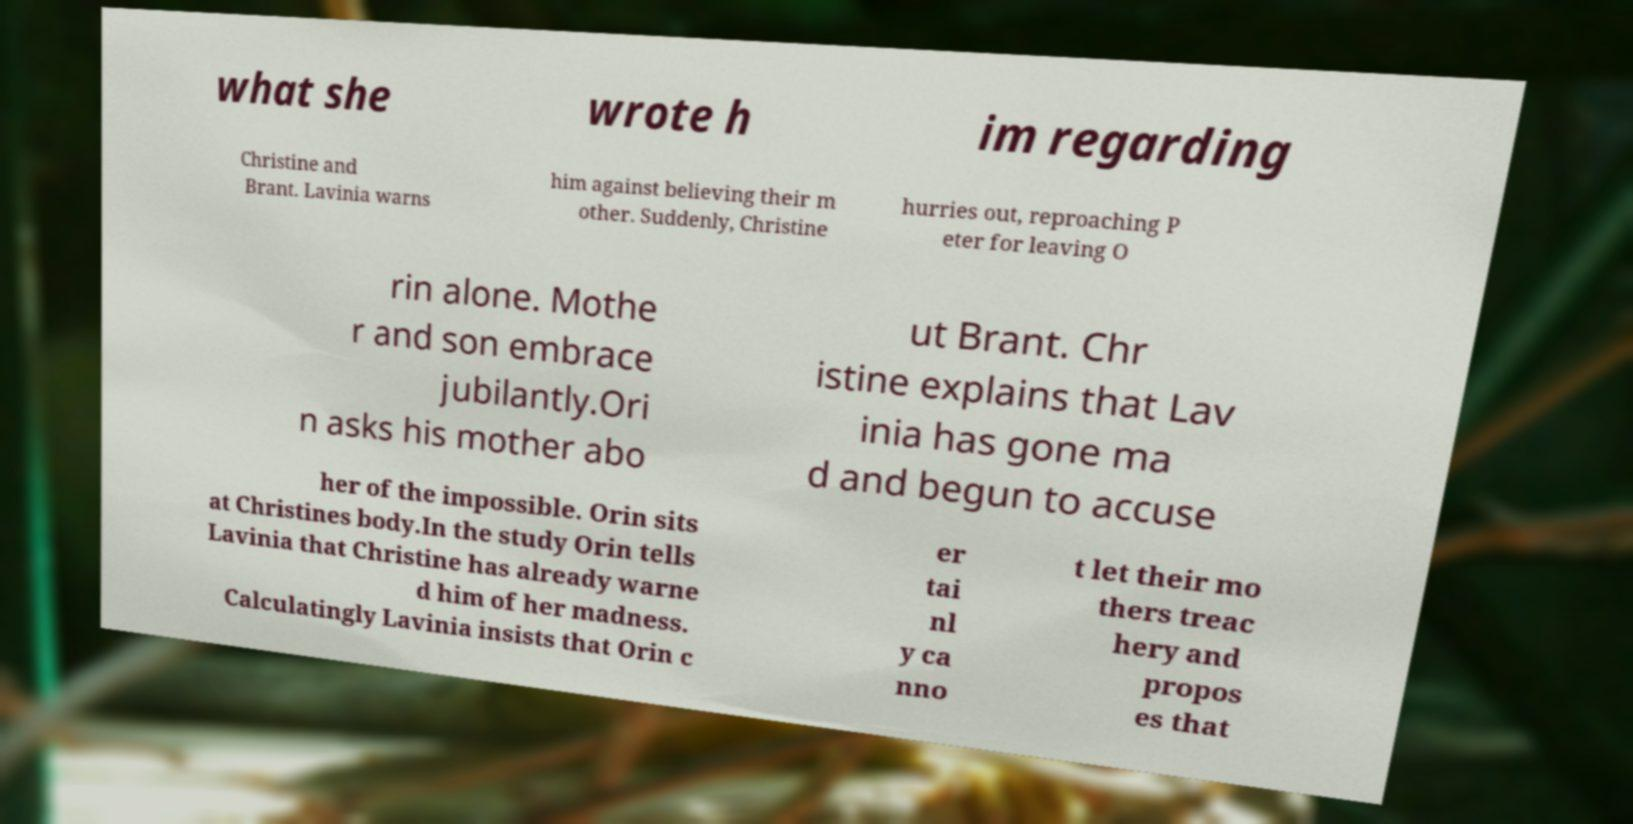Can you read and provide the text displayed in the image?This photo seems to have some interesting text. Can you extract and type it out for me? what she wrote h im regarding Christine and Brant. Lavinia warns him against believing their m other. Suddenly, Christine hurries out, reproaching P eter for leaving O rin alone. Mothe r and son embrace jubilantly.Ori n asks his mother abo ut Brant. Chr istine explains that Lav inia has gone ma d and begun to accuse her of the impossible. Orin sits at Christines body.In the study Orin tells Lavinia that Christine has already warne d him of her madness. Calculatingly Lavinia insists that Orin c er tai nl y ca nno t let their mo thers treac hery and propos es that 